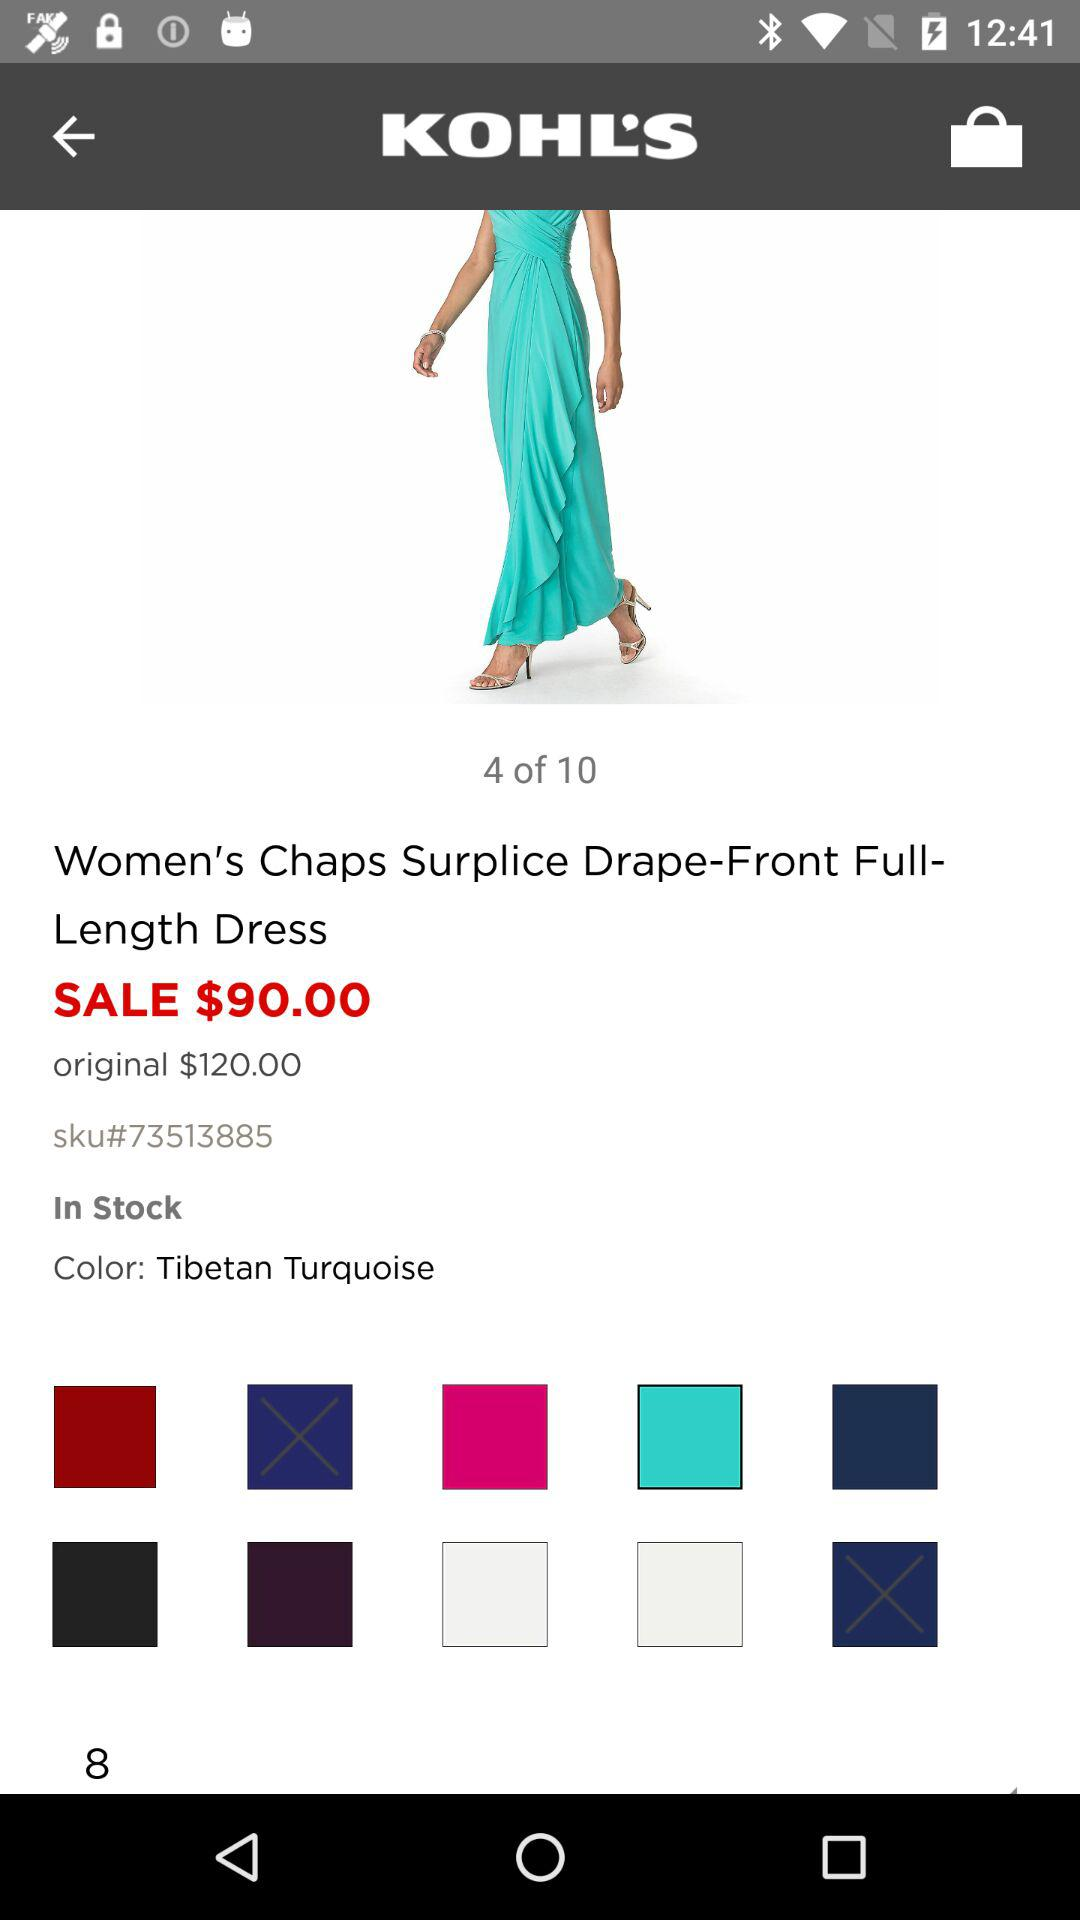What is the total number of images of the dress? The total number of images is 10. 